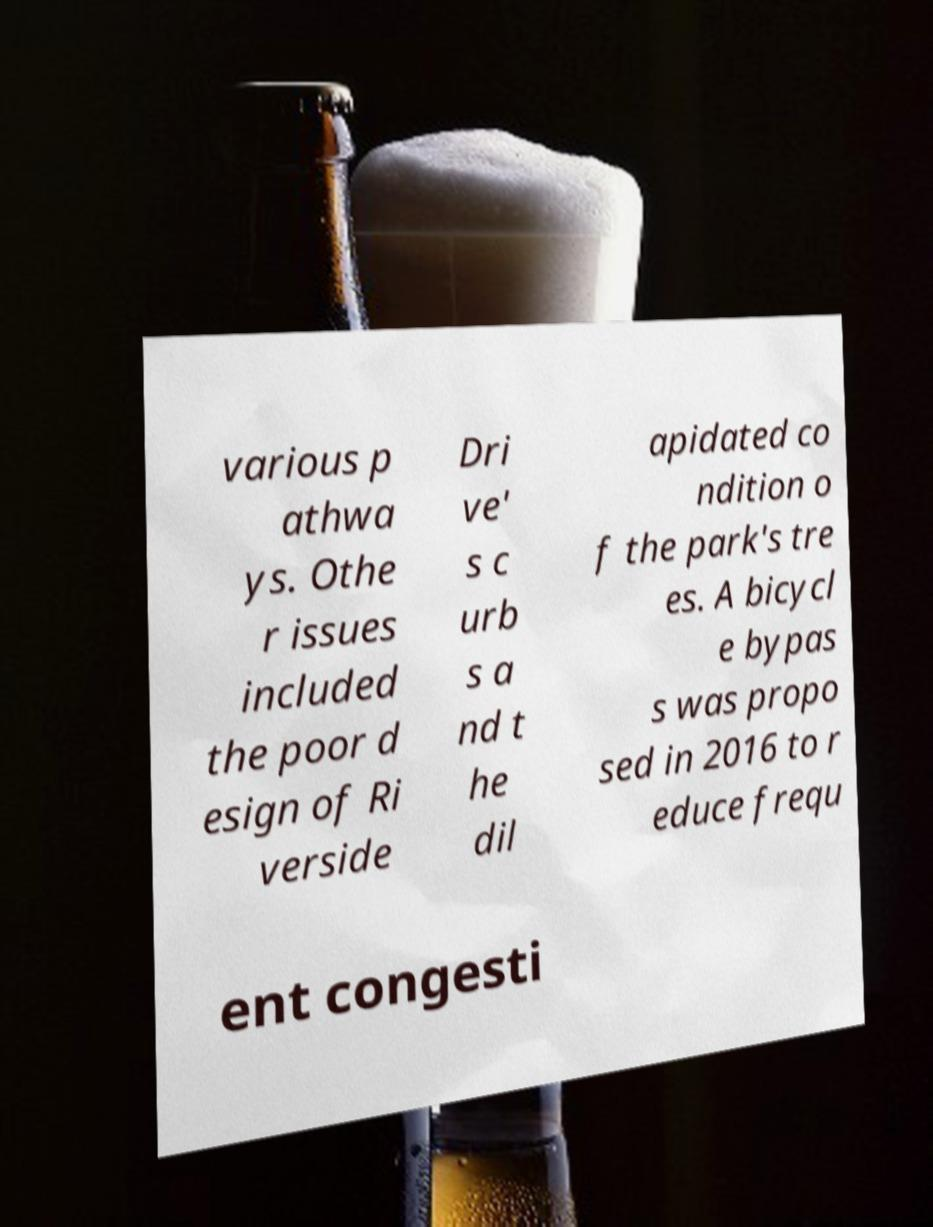Can you read and provide the text displayed in the image?This photo seems to have some interesting text. Can you extract and type it out for me? various p athwa ys. Othe r issues included the poor d esign of Ri verside Dri ve' s c urb s a nd t he dil apidated co ndition o f the park's tre es. A bicycl e bypas s was propo sed in 2016 to r educe frequ ent congesti 